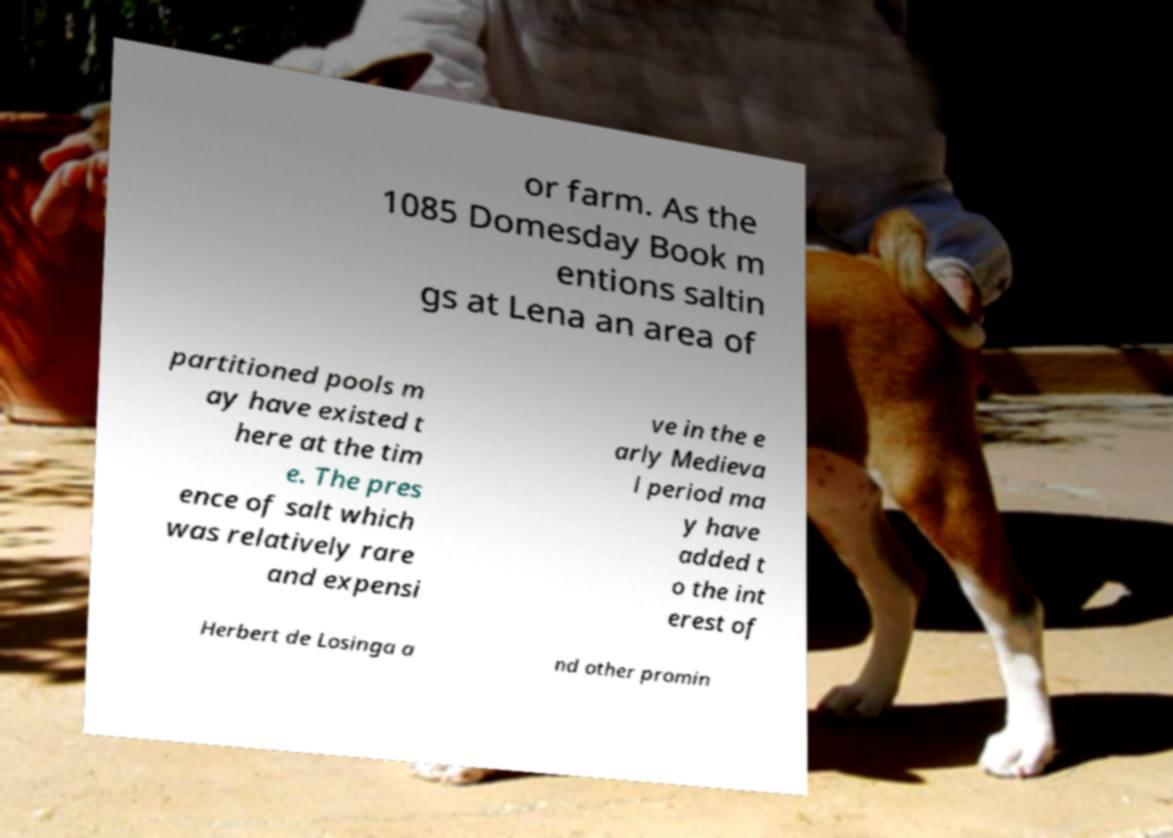Could you assist in decoding the text presented in this image and type it out clearly? or farm. As the 1085 Domesday Book m entions saltin gs at Lena an area of partitioned pools m ay have existed t here at the tim e. The pres ence of salt which was relatively rare and expensi ve in the e arly Medieva l period ma y have added t o the int erest of Herbert de Losinga a nd other promin 